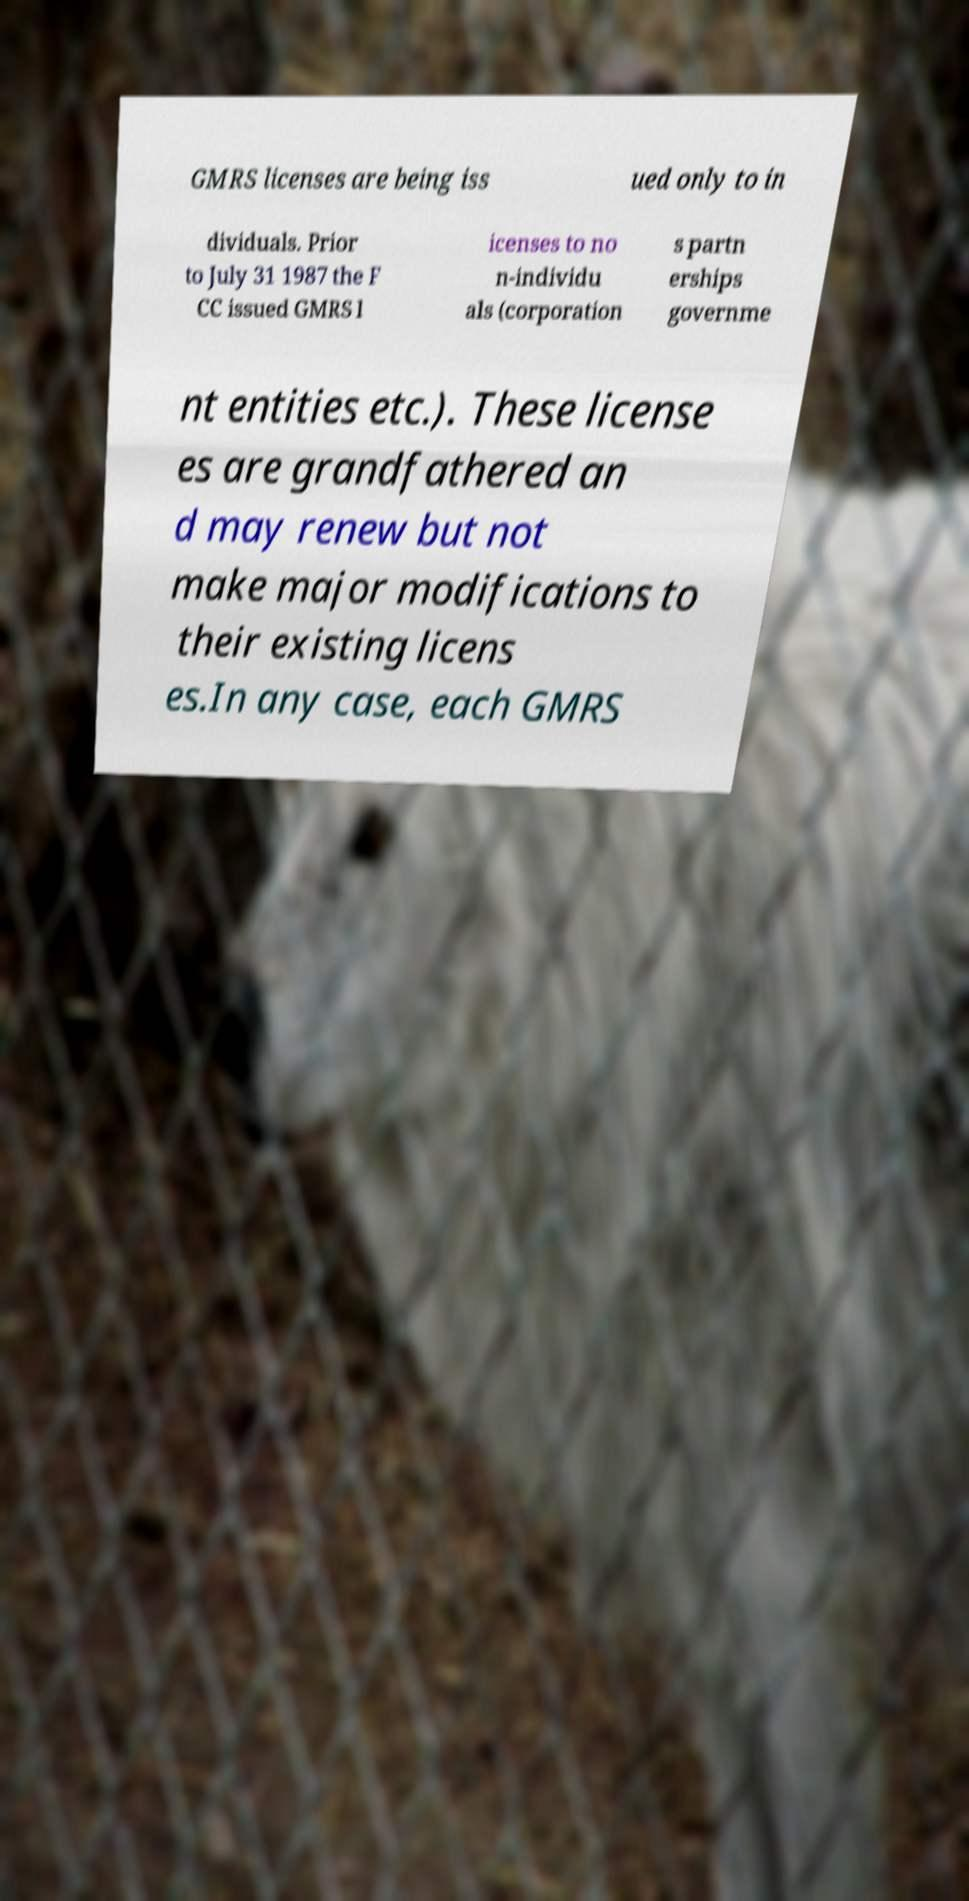What messages or text are displayed in this image? I need them in a readable, typed format. GMRS licenses are being iss ued only to in dividuals. Prior to July 31 1987 the F CC issued GMRS l icenses to no n-individu als (corporation s partn erships governme nt entities etc.). These license es are grandfathered an d may renew but not make major modifications to their existing licens es.In any case, each GMRS 